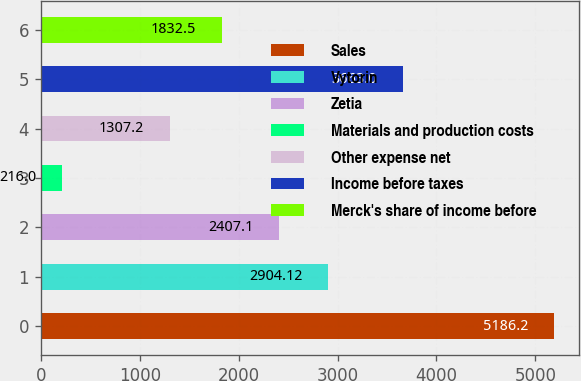<chart> <loc_0><loc_0><loc_500><loc_500><bar_chart><fcel>Sales<fcel>Vytorin<fcel>Zetia<fcel>Materials and production costs<fcel>Other expense net<fcel>Income before taxes<fcel>Merck's share of income before<nl><fcel>5186.2<fcel>2904.12<fcel>2407.1<fcel>216<fcel>1307.2<fcel>3663<fcel>1832.5<nl></chart> 